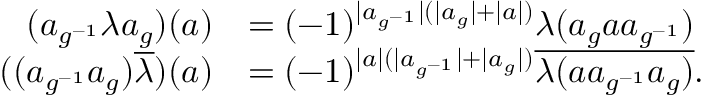Convert formula to latex. <formula><loc_0><loc_0><loc_500><loc_500>\begin{array} { r l } { ( a _ { g ^ { - 1 } } \lambda a _ { g } ) ( a ) } & { = ( - 1 ) ^ { | a _ { g ^ { - 1 } } | ( | a _ { g } | + | a | ) } \lambda ( a _ { g } a a _ { g ^ { - 1 } } ) } \\ { ( ( a _ { g ^ { - 1 } } a _ { g } ) \overline { \lambda } ) ( a ) } & { = ( - 1 ) ^ { | a | ( | a _ { g ^ { - 1 } } | + | a _ { g } | ) } \overline { { \lambda ( a a _ { g ^ { - 1 } } a _ { g } ) } } . } \end{array}</formula> 